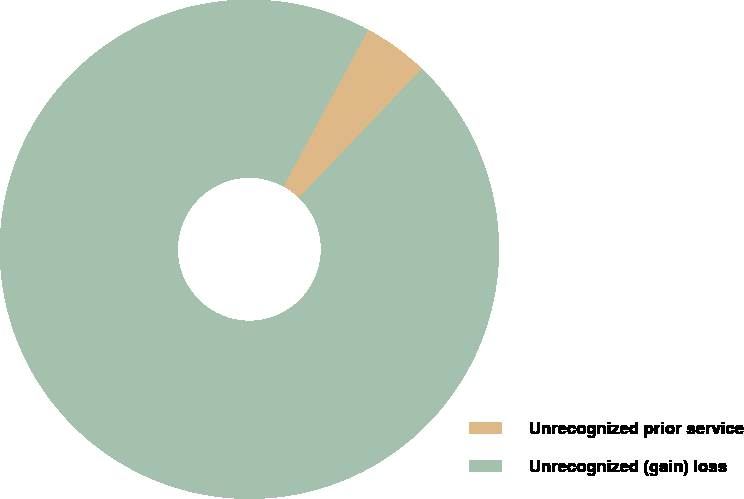Convert chart to OTSL. <chart><loc_0><loc_0><loc_500><loc_500><pie_chart><fcel>Unrecognized prior service<fcel>Unrecognized (gain) loss<nl><fcel>4.26%<fcel>95.74%<nl></chart> 